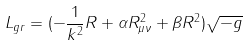<formula> <loc_0><loc_0><loc_500><loc_500>L _ { g r } = ( - \frac { 1 } { k ^ { 2 } } R + \alpha R _ { \mu \nu } ^ { 2 } + \beta R ^ { 2 } ) \sqrt { - g }</formula> 